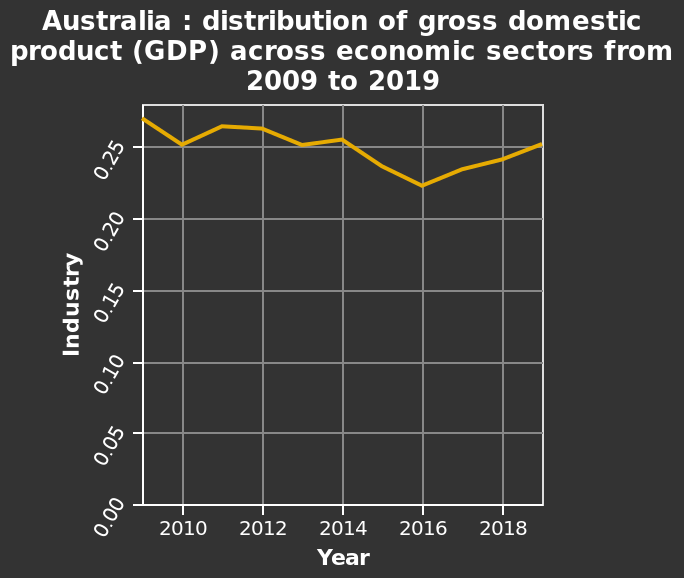<image>
Which year has the highest proportion of GDP from industry?  The year with the highest proportion of GDP from industry is 2009. What is the approximate proportion of GDP from industry in the year 2009?  The approximate proportion of GDP from industry in the year 2009 is 0.28. 